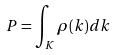<formula> <loc_0><loc_0><loc_500><loc_500>P = \int _ { K } \rho ( k ) d k</formula> 